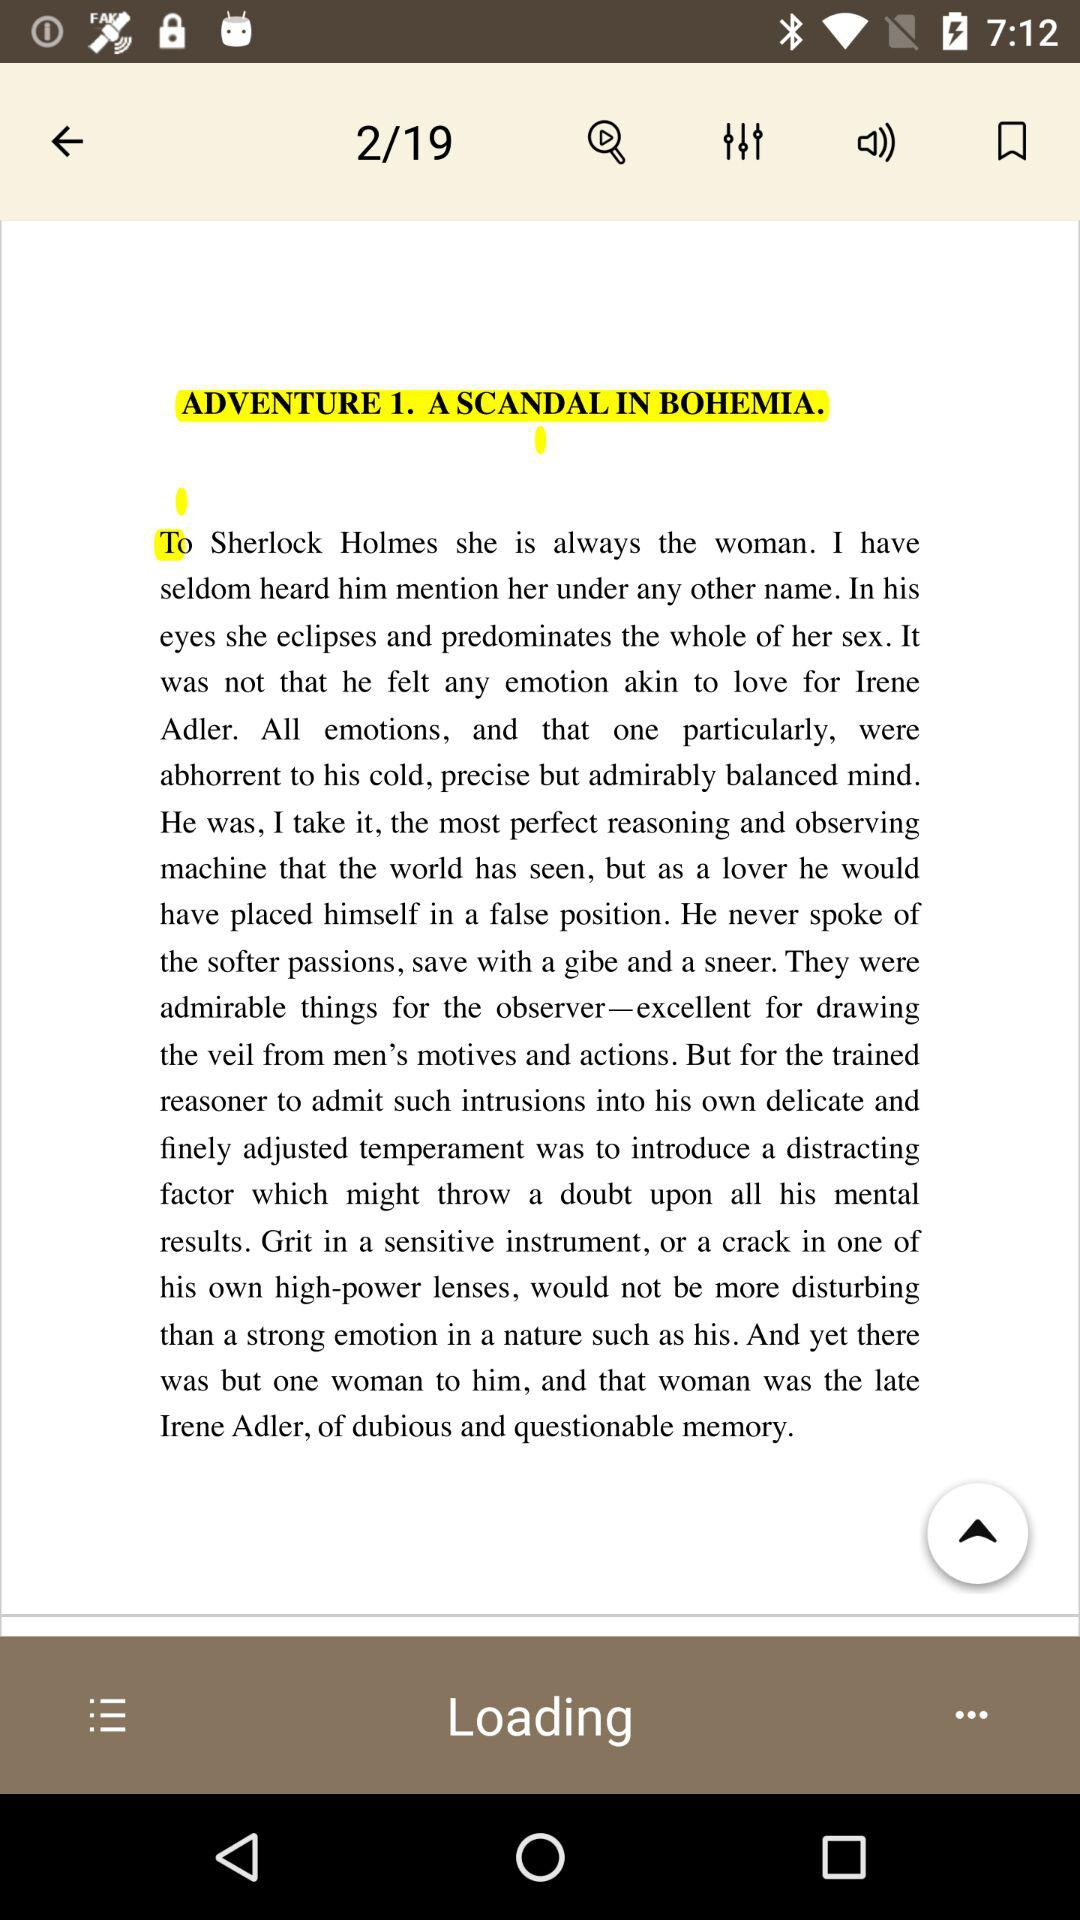What page number am I on? You are on page number 2. 